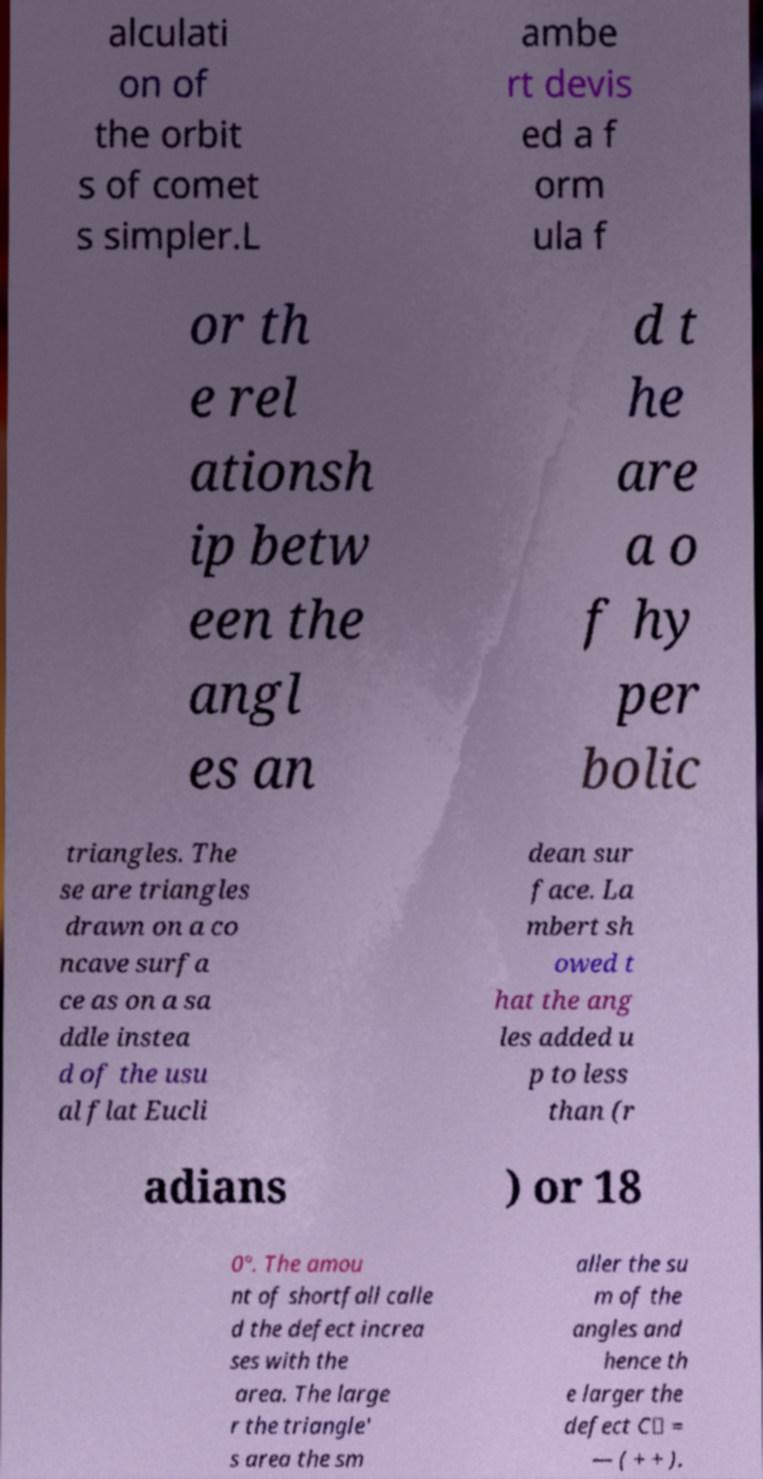Can you accurately transcribe the text from the provided image for me? alculati on of the orbit s of comet s simpler.L ambe rt devis ed a f orm ula f or th e rel ationsh ip betw een the angl es an d t he are a o f hy per bolic triangles. The se are triangles drawn on a co ncave surfa ce as on a sa ddle instea d of the usu al flat Eucli dean sur face. La mbert sh owed t hat the ang les added u p to less than (r adians ) or 18 0°. The amou nt of shortfall calle d the defect increa ses with the area. The large r the triangle' s area the sm aller the su m of the angles and hence th e larger the defect C△ = — ( + + ). 